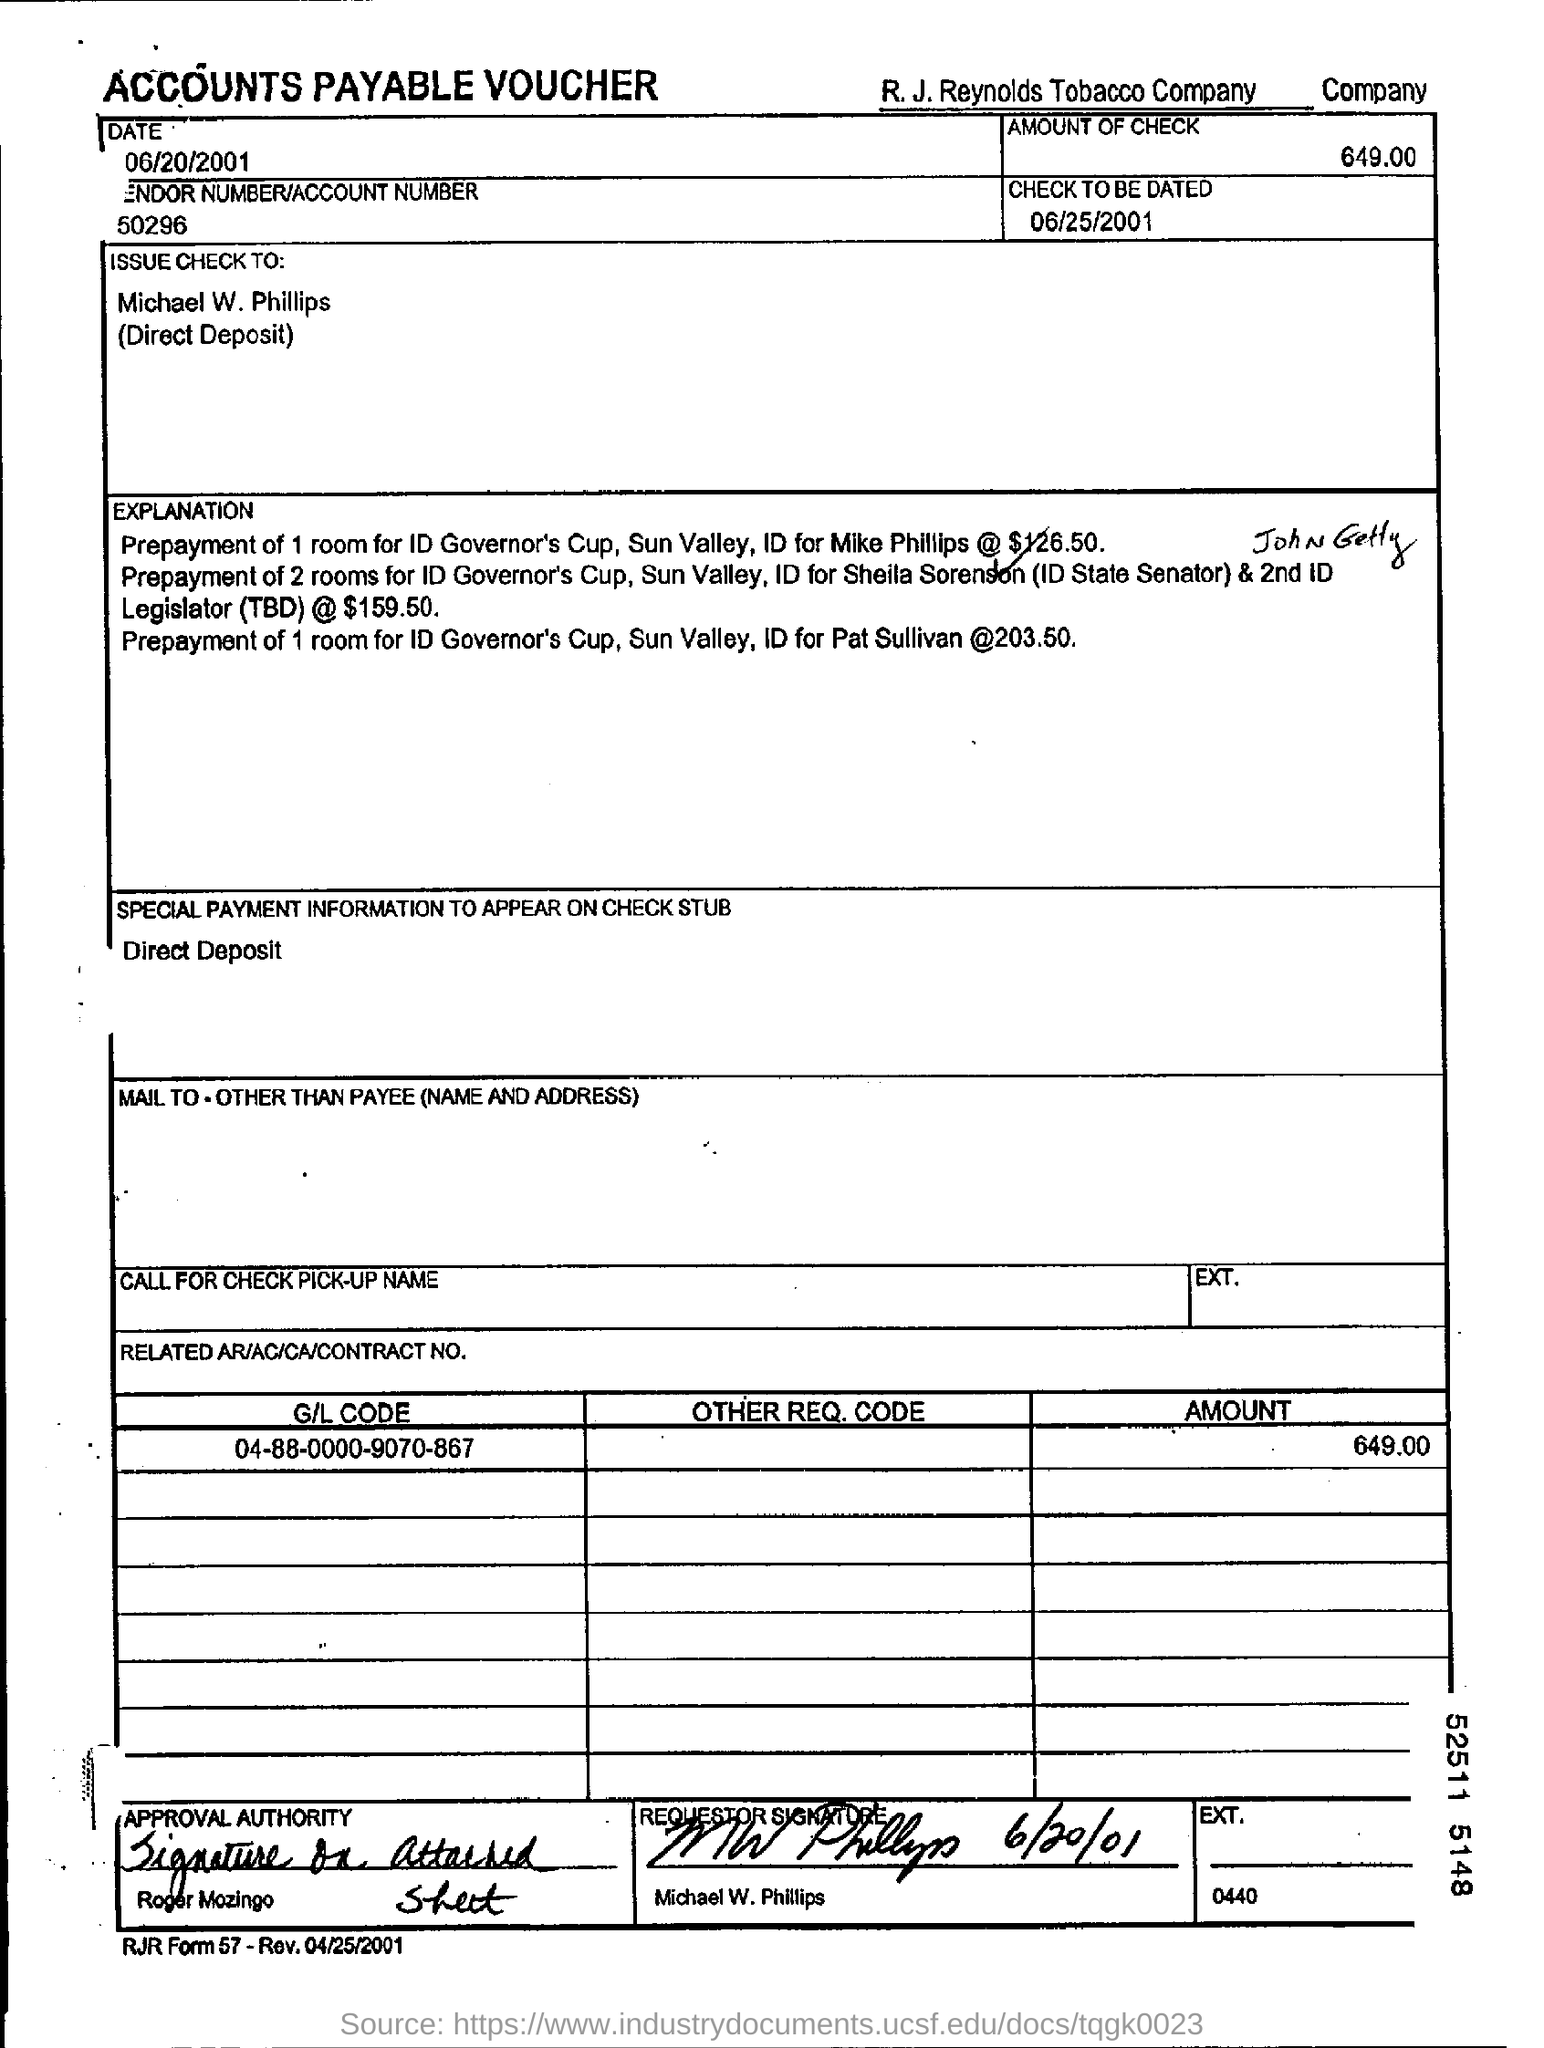What is the name of the company given at the top of the document?
Make the answer very short. R.J. Reynolds Tobacco company. What is the date mention in this document?
Offer a very short reply. 06/20/2001. What is the "amount of check"?
Ensure brevity in your answer.  649.00. What is "CHECK TO BE DATED"?
Your answer should be compact. 06/25/2001. To whom is the check issued?
Make the answer very short. Michael w. philips. 